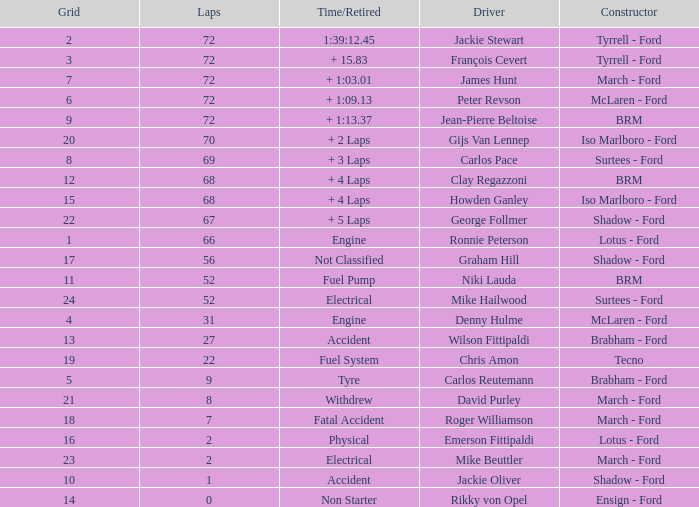What is the top lap that had a tyre time? 9.0. 